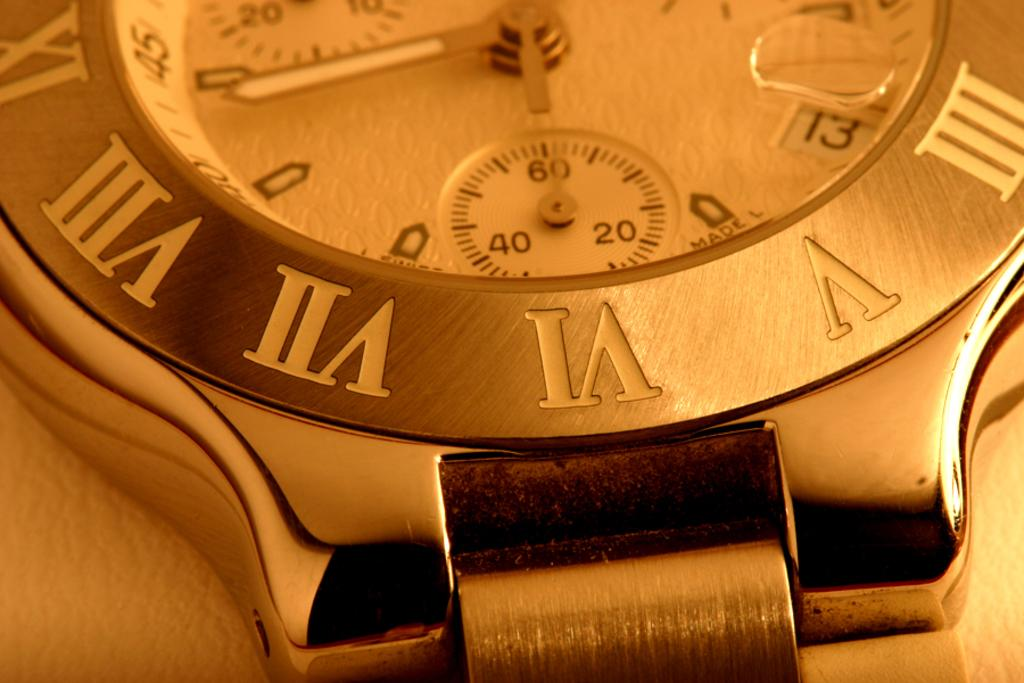<image>
Present a compact description of the photo's key features. A gold watch shows that it is the 13th day of the month. 